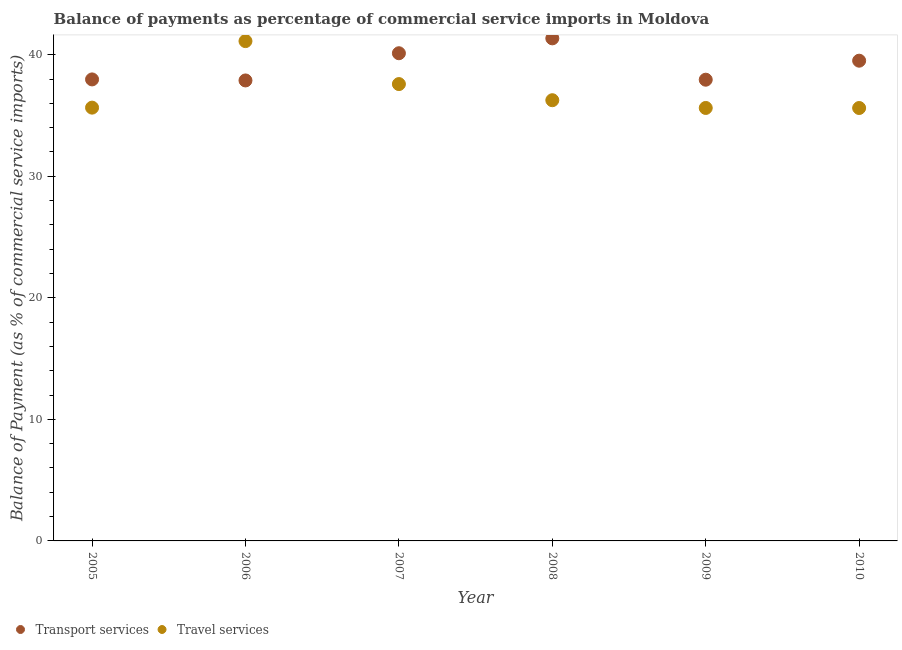How many different coloured dotlines are there?
Offer a terse response. 2. What is the balance of payments of transport services in 2008?
Make the answer very short. 41.34. Across all years, what is the maximum balance of payments of transport services?
Ensure brevity in your answer.  41.34. Across all years, what is the minimum balance of payments of transport services?
Offer a very short reply. 37.88. In which year was the balance of payments of travel services minimum?
Give a very brief answer. 2010. What is the total balance of payments of travel services in the graph?
Keep it short and to the point. 221.83. What is the difference between the balance of payments of travel services in 2009 and that in 2010?
Your response must be concise. 0. What is the difference between the balance of payments of travel services in 2007 and the balance of payments of transport services in 2008?
Offer a terse response. -3.76. What is the average balance of payments of travel services per year?
Keep it short and to the point. 36.97. In the year 2010, what is the difference between the balance of payments of travel services and balance of payments of transport services?
Your answer should be very brief. -3.89. What is the ratio of the balance of payments of transport services in 2005 to that in 2008?
Make the answer very short. 0.92. Is the balance of payments of travel services in 2007 less than that in 2010?
Ensure brevity in your answer.  No. What is the difference between the highest and the second highest balance of payments of transport services?
Your answer should be compact. 1.22. What is the difference between the highest and the lowest balance of payments of travel services?
Your answer should be compact. 5.5. Does the balance of payments of transport services monotonically increase over the years?
Offer a terse response. No. Is the balance of payments of transport services strictly greater than the balance of payments of travel services over the years?
Ensure brevity in your answer.  No. Are the values on the major ticks of Y-axis written in scientific E-notation?
Offer a very short reply. No. Where does the legend appear in the graph?
Provide a succinct answer. Bottom left. What is the title of the graph?
Make the answer very short. Balance of payments as percentage of commercial service imports in Moldova. Does "Taxes" appear as one of the legend labels in the graph?
Your answer should be very brief. No. What is the label or title of the X-axis?
Keep it short and to the point. Year. What is the label or title of the Y-axis?
Offer a terse response. Balance of Payment (as % of commercial service imports). What is the Balance of Payment (as % of commercial service imports) of Transport services in 2005?
Provide a short and direct response. 37.97. What is the Balance of Payment (as % of commercial service imports) of Travel services in 2005?
Make the answer very short. 35.64. What is the Balance of Payment (as % of commercial service imports) of Transport services in 2006?
Offer a terse response. 37.88. What is the Balance of Payment (as % of commercial service imports) of Travel services in 2006?
Offer a very short reply. 41.12. What is the Balance of Payment (as % of commercial service imports) in Transport services in 2007?
Your answer should be very brief. 40.12. What is the Balance of Payment (as % of commercial service imports) of Travel services in 2007?
Your answer should be compact. 37.58. What is the Balance of Payment (as % of commercial service imports) in Transport services in 2008?
Provide a succinct answer. 41.34. What is the Balance of Payment (as % of commercial service imports) in Travel services in 2008?
Provide a succinct answer. 36.26. What is the Balance of Payment (as % of commercial service imports) of Transport services in 2009?
Give a very brief answer. 37.94. What is the Balance of Payment (as % of commercial service imports) in Travel services in 2009?
Your answer should be very brief. 35.62. What is the Balance of Payment (as % of commercial service imports) of Transport services in 2010?
Provide a short and direct response. 39.51. What is the Balance of Payment (as % of commercial service imports) of Travel services in 2010?
Offer a terse response. 35.61. Across all years, what is the maximum Balance of Payment (as % of commercial service imports) of Transport services?
Provide a succinct answer. 41.34. Across all years, what is the maximum Balance of Payment (as % of commercial service imports) of Travel services?
Make the answer very short. 41.12. Across all years, what is the minimum Balance of Payment (as % of commercial service imports) of Transport services?
Your response must be concise. 37.88. Across all years, what is the minimum Balance of Payment (as % of commercial service imports) of Travel services?
Your answer should be very brief. 35.61. What is the total Balance of Payment (as % of commercial service imports) in Transport services in the graph?
Your response must be concise. 234.76. What is the total Balance of Payment (as % of commercial service imports) of Travel services in the graph?
Ensure brevity in your answer.  221.83. What is the difference between the Balance of Payment (as % of commercial service imports) in Transport services in 2005 and that in 2006?
Keep it short and to the point. 0.09. What is the difference between the Balance of Payment (as % of commercial service imports) in Travel services in 2005 and that in 2006?
Provide a succinct answer. -5.47. What is the difference between the Balance of Payment (as % of commercial service imports) in Transport services in 2005 and that in 2007?
Provide a succinct answer. -2.15. What is the difference between the Balance of Payment (as % of commercial service imports) in Travel services in 2005 and that in 2007?
Your response must be concise. -1.94. What is the difference between the Balance of Payment (as % of commercial service imports) in Transport services in 2005 and that in 2008?
Ensure brevity in your answer.  -3.38. What is the difference between the Balance of Payment (as % of commercial service imports) of Travel services in 2005 and that in 2008?
Provide a short and direct response. -0.61. What is the difference between the Balance of Payment (as % of commercial service imports) of Transport services in 2005 and that in 2009?
Offer a terse response. 0.02. What is the difference between the Balance of Payment (as % of commercial service imports) in Travel services in 2005 and that in 2009?
Keep it short and to the point. 0.03. What is the difference between the Balance of Payment (as % of commercial service imports) in Transport services in 2005 and that in 2010?
Provide a short and direct response. -1.54. What is the difference between the Balance of Payment (as % of commercial service imports) of Travel services in 2005 and that in 2010?
Ensure brevity in your answer.  0.03. What is the difference between the Balance of Payment (as % of commercial service imports) of Transport services in 2006 and that in 2007?
Your answer should be very brief. -2.24. What is the difference between the Balance of Payment (as % of commercial service imports) of Travel services in 2006 and that in 2007?
Ensure brevity in your answer.  3.54. What is the difference between the Balance of Payment (as % of commercial service imports) in Transport services in 2006 and that in 2008?
Provide a short and direct response. -3.46. What is the difference between the Balance of Payment (as % of commercial service imports) of Travel services in 2006 and that in 2008?
Keep it short and to the point. 4.86. What is the difference between the Balance of Payment (as % of commercial service imports) of Transport services in 2006 and that in 2009?
Make the answer very short. -0.06. What is the difference between the Balance of Payment (as % of commercial service imports) in Travel services in 2006 and that in 2009?
Your answer should be compact. 5.5. What is the difference between the Balance of Payment (as % of commercial service imports) of Transport services in 2006 and that in 2010?
Ensure brevity in your answer.  -1.63. What is the difference between the Balance of Payment (as % of commercial service imports) in Travel services in 2006 and that in 2010?
Provide a succinct answer. 5.5. What is the difference between the Balance of Payment (as % of commercial service imports) of Transport services in 2007 and that in 2008?
Ensure brevity in your answer.  -1.22. What is the difference between the Balance of Payment (as % of commercial service imports) of Travel services in 2007 and that in 2008?
Keep it short and to the point. 1.33. What is the difference between the Balance of Payment (as % of commercial service imports) of Transport services in 2007 and that in 2009?
Your response must be concise. 2.18. What is the difference between the Balance of Payment (as % of commercial service imports) in Travel services in 2007 and that in 2009?
Your response must be concise. 1.96. What is the difference between the Balance of Payment (as % of commercial service imports) in Transport services in 2007 and that in 2010?
Provide a succinct answer. 0.61. What is the difference between the Balance of Payment (as % of commercial service imports) in Travel services in 2007 and that in 2010?
Provide a succinct answer. 1.97. What is the difference between the Balance of Payment (as % of commercial service imports) in Transport services in 2008 and that in 2009?
Offer a terse response. 3.4. What is the difference between the Balance of Payment (as % of commercial service imports) in Travel services in 2008 and that in 2009?
Offer a very short reply. 0.64. What is the difference between the Balance of Payment (as % of commercial service imports) of Transport services in 2008 and that in 2010?
Ensure brevity in your answer.  1.84. What is the difference between the Balance of Payment (as % of commercial service imports) in Travel services in 2008 and that in 2010?
Offer a terse response. 0.64. What is the difference between the Balance of Payment (as % of commercial service imports) of Transport services in 2009 and that in 2010?
Make the answer very short. -1.56. What is the difference between the Balance of Payment (as % of commercial service imports) of Travel services in 2009 and that in 2010?
Provide a short and direct response. 0. What is the difference between the Balance of Payment (as % of commercial service imports) of Transport services in 2005 and the Balance of Payment (as % of commercial service imports) of Travel services in 2006?
Provide a succinct answer. -3.15. What is the difference between the Balance of Payment (as % of commercial service imports) of Transport services in 2005 and the Balance of Payment (as % of commercial service imports) of Travel services in 2007?
Your response must be concise. 0.38. What is the difference between the Balance of Payment (as % of commercial service imports) of Transport services in 2005 and the Balance of Payment (as % of commercial service imports) of Travel services in 2008?
Offer a terse response. 1.71. What is the difference between the Balance of Payment (as % of commercial service imports) of Transport services in 2005 and the Balance of Payment (as % of commercial service imports) of Travel services in 2009?
Keep it short and to the point. 2.35. What is the difference between the Balance of Payment (as % of commercial service imports) of Transport services in 2005 and the Balance of Payment (as % of commercial service imports) of Travel services in 2010?
Offer a terse response. 2.35. What is the difference between the Balance of Payment (as % of commercial service imports) in Transport services in 2006 and the Balance of Payment (as % of commercial service imports) in Travel services in 2007?
Offer a very short reply. 0.3. What is the difference between the Balance of Payment (as % of commercial service imports) of Transport services in 2006 and the Balance of Payment (as % of commercial service imports) of Travel services in 2008?
Ensure brevity in your answer.  1.63. What is the difference between the Balance of Payment (as % of commercial service imports) of Transport services in 2006 and the Balance of Payment (as % of commercial service imports) of Travel services in 2009?
Provide a short and direct response. 2.26. What is the difference between the Balance of Payment (as % of commercial service imports) in Transport services in 2006 and the Balance of Payment (as % of commercial service imports) in Travel services in 2010?
Your answer should be very brief. 2.27. What is the difference between the Balance of Payment (as % of commercial service imports) in Transport services in 2007 and the Balance of Payment (as % of commercial service imports) in Travel services in 2008?
Offer a very short reply. 3.86. What is the difference between the Balance of Payment (as % of commercial service imports) in Transport services in 2007 and the Balance of Payment (as % of commercial service imports) in Travel services in 2009?
Provide a succinct answer. 4.5. What is the difference between the Balance of Payment (as % of commercial service imports) of Transport services in 2007 and the Balance of Payment (as % of commercial service imports) of Travel services in 2010?
Give a very brief answer. 4.51. What is the difference between the Balance of Payment (as % of commercial service imports) in Transport services in 2008 and the Balance of Payment (as % of commercial service imports) in Travel services in 2009?
Your answer should be very brief. 5.73. What is the difference between the Balance of Payment (as % of commercial service imports) of Transport services in 2008 and the Balance of Payment (as % of commercial service imports) of Travel services in 2010?
Provide a short and direct response. 5.73. What is the difference between the Balance of Payment (as % of commercial service imports) in Transport services in 2009 and the Balance of Payment (as % of commercial service imports) in Travel services in 2010?
Keep it short and to the point. 2.33. What is the average Balance of Payment (as % of commercial service imports) of Transport services per year?
Give a very brief answer. 39.13. What is the average Balance of Payment (as % of commercial service imports) in Travel services per year?
Your response must be concise. 36.97. In the year 2005, what is the difference between the Balance of Payment (as % of commercial service imports) in Transport services and Balance of Payment (as % of commercial service imports) in Travel services?
Provide a short and direct response. 2.32. In the year 2006, what is the difference between the Balance of Payment (as % of commercial service imports) of Transport services and Balance of Payment (as % of commercial service imports) of Travel services?
Ensure brevity in your answer.  -3.24. In the year 2007, what is the difference between the Balance of Payment (as % of commercial service imports) of Transport services and Balance of Payment (as % of commercial service imports) of Travel services?
Your answer should be very brief. 2.54. In the year 2008, what is the difference between the Balance of Payment (as % of commercial service imports) of Transport services and Balance of Payment (as % of commercial service imports) of Travel services?
Provide a succinct answer. 5.09. In the year 2009, what is the difference between the Balance of Payment (as % of commercial service imports) in Transport services and Balance of Payment (as % of commercial service imports) in Travel services?
Offer a very short reply. 2.32. In the year 2010, what is the difference between the Balance of Payment (as % of commercial service imports) in Transport services and Balance of Payment (as % of commercial service imports) in Travel services?
Offer a terse response. 3.89. What is the ratio of the Balance of Payment (as % of commercial service imports) in Transport services in 2005 to that in 2006?
Keep it short and to the point. 1. What is the ratio of the Balance of Payment (as % of commercial service imports) of Travel services in 2005 to that in 2006?
Provide a succinct answer. 0.87. What is the ratio of the Balance of Payment (as % of commercial service imports) of Transport services in 2005 to that in 2007?
Offer a very short reply. 0.95. What is the ratio of the Balance of Payment (as % of commercial service imports) of Travel services in 2005 to that in 2007?
Offer a very short reply. 0.95. What is the ratio of the Balance of Payment (as % of commercial service imports) of Transport services in 2005 to that in 2008?
Offer a terse response. 0.92. What is the ratio of the Balance of Payment (as % of commercial service imports) of Travel services in 2005 to that in 2008?
Your answer should be compact. 0.98. What is the ratio of the Balance of Payment (as % of commercial service imports) in Transport services in 2005 to that in 2010?
Ensure brevity in your answer.  0.96. What is the ratio of the Balance of Payment (as % of commercial service imports) in Transport services in 2006 to that in 2007?
Your answer should be compact. 0.94. What is the ratio of the Balance of Payment (as % of commercial service imports) of Travel services in 2006 to that in 2007?
Keep it short and to the point. 1.09. What is the ratio of the Balance of Payment (as % of commercial service imports) of Transport services in 2006 to that in 2008?
Provide a succinct answer. 0.92. What is the ratio of the Balance of Payment (as % of commercial service imports) in Travel services in 2006 to that in 2008?
Provide a succinct answer. 1.13. What is the ratio of the Balance of Payment (as % of commercial service imports) of Transport services in 2006 to that in 2009?
Your response must be concise. 1. What is the ratio of the Balance of Payment (as % of commercial service imports) of Travel services in 2006 to that in 2009?
Make the answer very short. 1.15. What is the ratio of the Balance of Payment (as % of commercial service imports) of Transport services in 2006 to that in 2010?
Provide a short and direct response. 0.96. What is the ratio of the Balance of Payment (as % of commercial service imports) of Travel services in 2006 to that in 2010?
Make the answer very short. 1.15. What is the ratio of the Balance of Payment (as % of commercial service imports) in Transport services in 2007 to that in 2008?
Offer a very short reply. 0.97. What is the ratio of the Balance of Payment (as % of commercial service imports) in Travel services in 2007 to that in 2008?
Offer a very short reply. 1.04. What is the ratio of the Balance of Payment (as % of commercial service imports) in Transport services in 2007 to that in 2009?
Offer a terse response. 1.06. What is the ratio of the Balance of Payment (as % of commercial service imports) of Travel services in 2007 to that in 2009?
Provide a short and direct response. 1.06. What is the ratio of the Balance of Payment (as % of commercial service imports) in Transport services in 2007 to that in 2010?
Your answer should be very brief. 1.02. What is the ratio of the Balance of Payment (as % of commercial service imports) of Travel services in 2007 to that in 2010?
Provide a succinct answer. 1.06. What is the ratio of the Balance of Payment (as % of commercial service imports) of Transport services in 2008 to that in 2009?
Keep it short and to the point. 1.09. What is the ratio of the Balance of Payment (as % of commercial service imports) of Travel services in 2008 to that in 2009?
Provide a succinct answer. 1.02. What is the ratio of the Balance of Payment (as % of commercial service imports) in Transport services in 2008 to that in 2010?
Offer a very short reply. 1.05. What is the ratio of the Balance of Payment (as % of commercial service imports) of Travel services in 2008 to that in 2010?
Offer a very short reply. 1.02. What is the ratio of the Balance of Payment (as % of commercial service imports) in Transport services in 2009 to that in 2010?
Ensure brevity in your answer.  0.96. What is the difference between the highest and the second highest Balance of Payment (as % of commercial service imports) in Transport services?
Offer a very short reply. 1.22. What is the difference between the highest and the second highest Balance of Payment (as % of commercial service imports) of Travel services?
Your response must be concise. 3.54. What is the difference between the highest and the lowest Balance of Payment (as % of commercial service imports) of Transport services?
Ensure brevity in your answer.  3.46. What is the difference between the highest and the lowest Balance of Payment (as % of commercial service imports) of Travel services?
Keep it short and to the point. 5.5. 